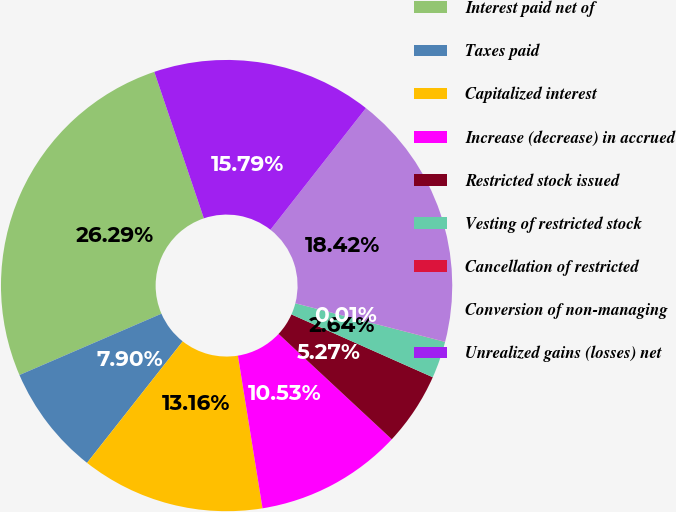Convert chart. <chart><loc_0><loc_0><loc_500><loc_500><pie_chart><fcel>Interest paid net of<fcel>Taxes paid<fcel>Capitalized interest<fcel>Increase (decrease) in accrued<fcel>Restricted stock issued<fcel>Vesting of restricted stock<fcel>Cancellation of restricted<fcel>Conversion of non-managing<fcel>Unrealized gains (losses) net<nl><fcel>26.3%<fcel>7.9%<fcel>13.16%<fcel>10.53%<fcel>5.27%<fcel>2.64%<fcel>0.01%<fcel>18.42%<fcel>15.79%<nl></chart> 